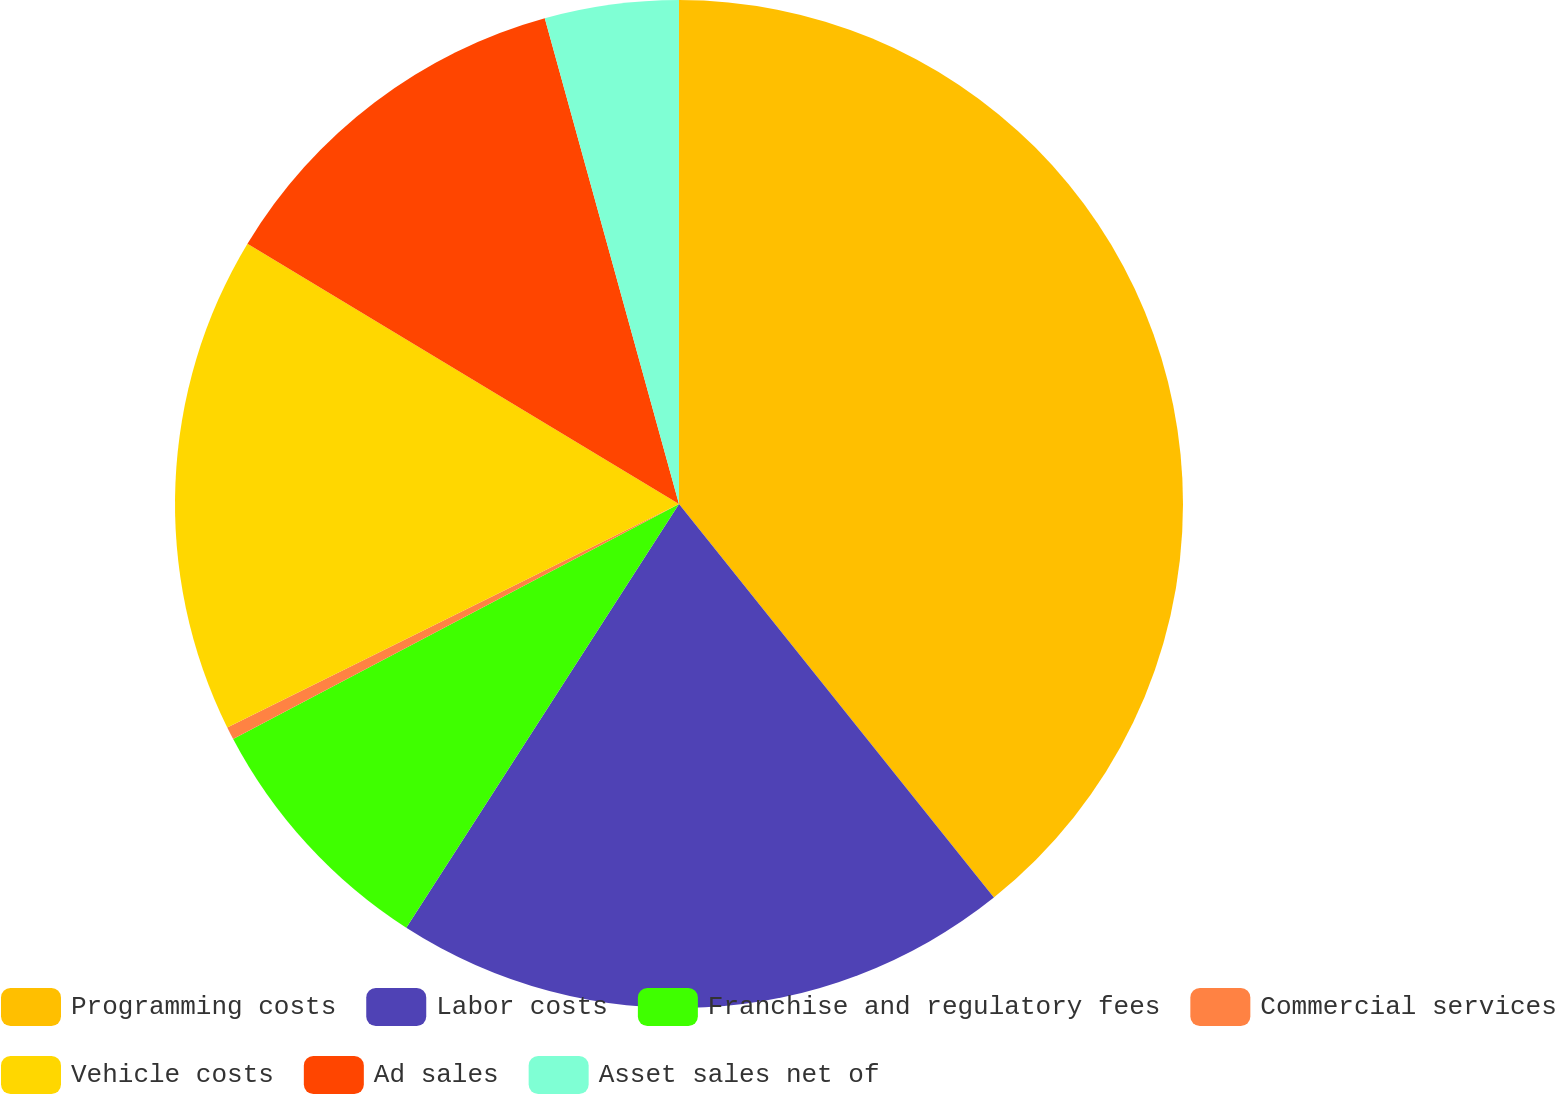Convert chart. <chart><loc_0><loc_0><loc_500><loc_500><pie_chart><fcel>Programming costs<fcel>Labor costs<fcel>Franchise and regulatory fees<fcel>Commercial services<fcel>Vehicle costs<fcel>Ad sales<fcel>Asset sales net of<nl><fcel>39.26%<fcel>19.84%<fcel>8.18%<fcel>0.41%<fcel>15.95%<fcel>12.07%<fcel>4.29%<nl></chart> 